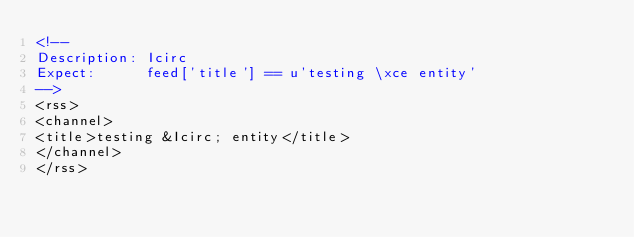Convert code to text. <code><loc_0><loc_0><loc_500><loc_500><_XML_><!--
Description: Icirc
Expect:      feed['title'] == u'testing \xce entity'
-->
<rss>
<channel>
<title>testing &Icirc; entity</title>
</channel>
</rss></code> 